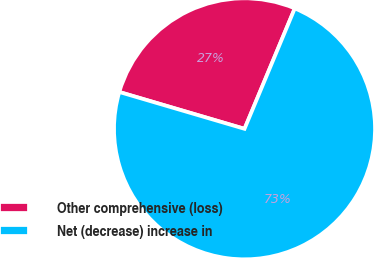Convert chart. <chart><loc_0><loc_0><loc_500><loc_500><pie_chart><fcel>Other comprehensive (loss)<fcel>Net (decrease) increase in<nl><fcel>26.74%<fcel>73.26%<nl></chart> 